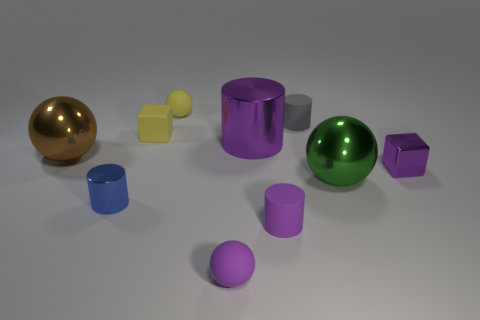How many other objects have the same shape as the small blue metal thing?
Give a very brief answer. 3. Is there a small green object that has the same material as the tiny gray cylinder?
Ensure brevity in your answer.  No. What is the material of the big sphere left of the small rubber ball that is to the left of the purple ball?
Give a very brief answer. Metal. What is the size of the sphere that is left of the small yellow ball?
Keep it short and to the point. Large. There is a rubber block; does it have the same color as the rubber sphere in front of the purple metal cylinder?
Provide a succinct answer. No. Are there any other cylinders that have the same color as the large shiny cylinder?
Ensure brevity in your answer.  Yes. Is the big green sphere made of the same material as the purple cylinder that is behind the small metallic cube?
Keep it short and to the point. Yes. What number of small objects are either green matte blocks or gray cylinders?
Ensure brevity in your answer.  1. There is a thing that is the same color as the tiny rubber block; what material is it?
Offer a terse response. Rubber. Is the number of purple matte cylinders less than the number of tiny purple matte blocks?
Provide a short and direct response. No. 